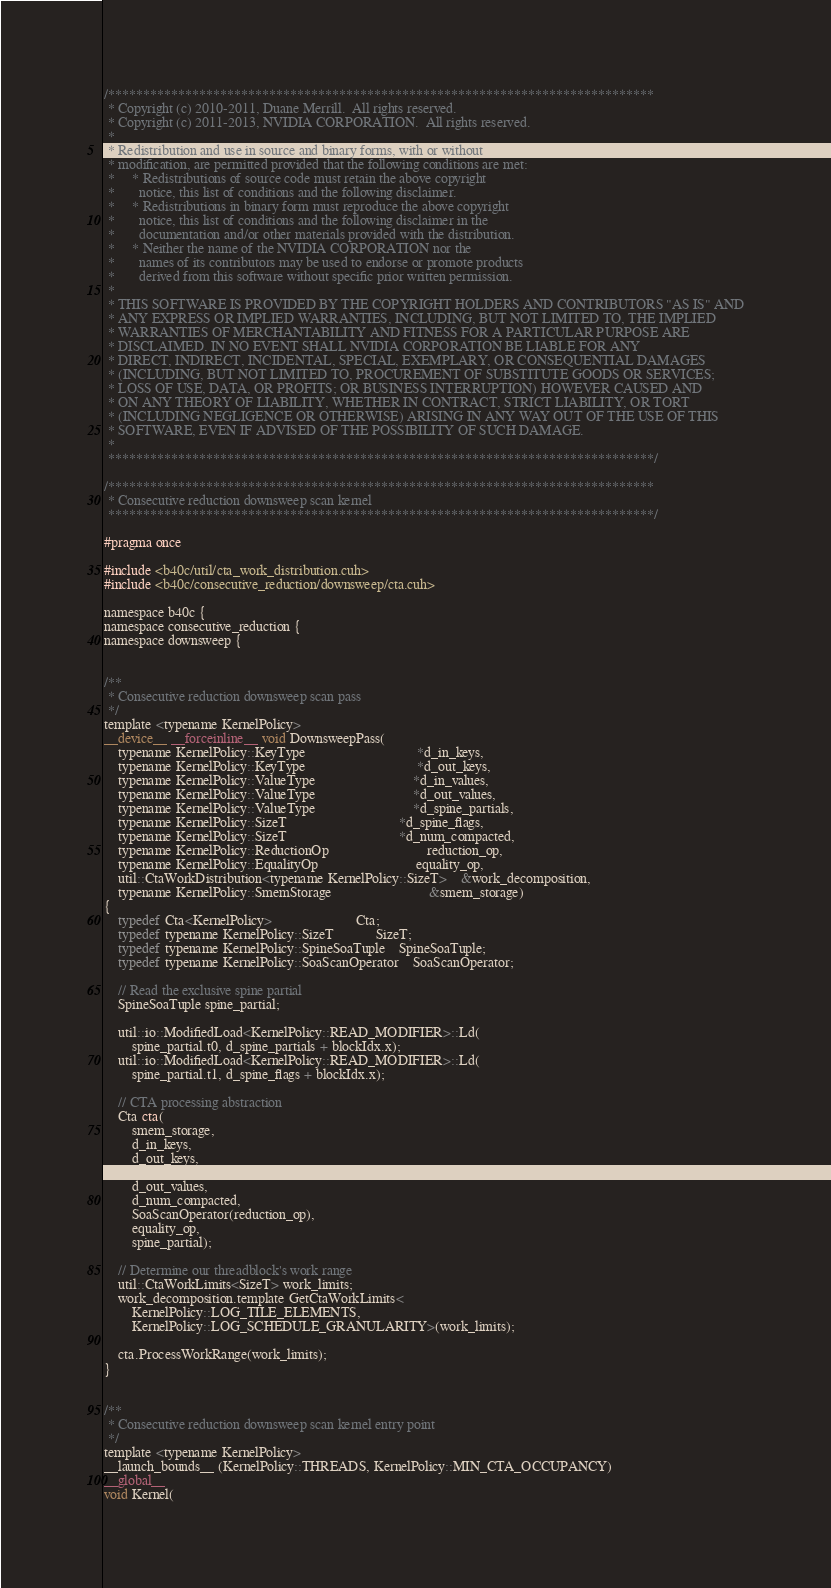<code> <loc_0><loc_0><loc_500><loc_500><_Cuda_>/******************************************************************************
 * Copyright (c) 2010-2011, Duane Merrill.  All rights reserved.
 * Copyright (c) 2011-2013, NVIDIA CORPORATION.  All rights reserved.
 * 
 * Redistribution and use in source and binary forms, with or without
 * modification, are permitted provided that the following conditions are met:
 *     * Redistributions of source code must retain the above copyright
 *       notice, this list of conditions and the following disclaimer.
 *     * Redistributions in binary form must reproduce the above copyright
 *       notice, this list of conditions and the following disclaimer in the
 *       documentation and/or other materials provided with the distribution.
 *     * Neither the name of the NVIDIA CORPORATION nor the
 *       names of its contributors may be used to endorse or promote products
 *       derived from this software without specific prior written permission.
 * 
 * THIS SOFTWARE IS PROVIDED BY THE COPYRIGHT HOLDERS AND CONTRIBUTORS "AS IS" AND
 * ANY EXPRESS OR IMPLIED WARRANTIES, INCLUDING, BUT NOT LIMITED TO, THE IMPLIED
 * WARRANTIES OF MERCHANTABILITY AND FITNESS FOR A PARTICULAR PURPOSE ARE
 * DISCLAIMED. IN NO EVENT SHALL NVIDIA CORPORATION BE LIABLE FOR ANY
 * DIRECT, INDIRECT, INCIDENTAL, SPECIAL, EXEMPLARY, OR CONSEQUENTIAL DAMAGES
 * (INCLUDING, BUT NOT LIMITED TO, PROCUREMENT OF SUBSTITUTE GOODS OR SERVICES;
 * LOSS OF USE, DATA, OR PROFITS; OR BUSINESS INTERRUPTION) HOWEVER CAUSED AND
 * ON ANY THEORY OF LIABILITY, WHETHER IN CONTRACT, STRICT LIABILITY, OR TORT
 * (INCLUDING NEGLIGENCE OR OTHERWISE) ARISING IN ANY WAY OUT OF THE USE OF THIS
 * SOFTWARE, EVEN IF ADVISED OF THE POSSIBILITY OF SUCH DAMAGE.
 *
 ******************************************************************************/

/******************************************************************************
 * Consecutive reduction downsweep scan kernel
 ******************************************************************************/

#pragma once

#include <b40c/util/cta_work_distribution.cuh>
#include <b40c/consecutive_reduction/downsweep/cta.cuh>

namespace b40c {
namespace consecutive_reduction {
namespace downsweep {


/**
 * Consecutive reduction downsweep scan pass
 */
template <typename KernelPolicy>
__device__ __forceinline__ void DownsweepPass(
	typename KernelPolicy::KeyType 								*d_in_keys,
	typename KernelPolicy::KeyType								*d_out_keys,
	typename KernelPolicy::ValueType 							*d_in_values,
	typename KernelPolicy::ValueType 							*d_out_values,
	typename KernelPolicy::ValueType 							*d_spine_partials,
	typename KernelPolicy::SizeT 								*d_spine_flags,
	typename KernelPolicy::SizeT								*d_num_compacted,
	typename KernelPolicy::ReductionOp 							reduction_op,
	typename KernelPolicy::EqualityOp							equality_op,
	util::CtaWorkDistribution<typename KernelPolicy::SizeT> 	&work_decomposition,
	typename KernelPolicy::SmemStorage							&smem_storage)
{
	typedef Cta<KernelPolicy> 						Cta;
	typedef typename KernelPolicy::SizeT 			SizeT;
	typedef typename KernelPolicy::SpineSoaTuple	SpineSoaTuple;
	typedef typename KernelPolicy::SoaScanOperator	SoaScanOperator;

	// Read the exclusive spine partial
	SpineSoaTuple spine_partial;

	util::io::ModifiedLoad<KernelPolicy::READ_MODIFIER>::Ld(
		spine_partial.t0, d_spine_partials + blockIdx.x);
	util::io::ModifiedLoad<KernelPolicy::READ_MODIFIER>::Ld(
		spine_partial.t1, d_spine_flags + blockIdx.x);

	// CTA processing abstraction
	Cta cta(
		smem_storage,
		d_in_keys,
		d_out_keys,
		d_in_values,
		d_out_values,
		d_num_compacted,
		SoaScanOperator(reduction_op),
		equality_op,
		spine_partial);

	// Determine our threadblock's work range
	util::CtaWorkLimits<SizeT> work_limits;
	work_decomposition.template GetCtaWorkLimits<
		KernelPolicy::LOG_TILE_ELEMENTS,
		KernelPolicy::LOG_SCHEDULE_GRANULARITY>(work_limits);

	cta.ProcessWorkRange(work_limits);
}


/**
 * Consecutive reduction downsweep scan kernel entry point
 */
template <typename KernelPolicy>
__launch_bounds__ (KernelPolicy::THREADS, KernelPolicy::MIN_CTA_OCCUPANCY)
__global__
void Kernel(</code> 